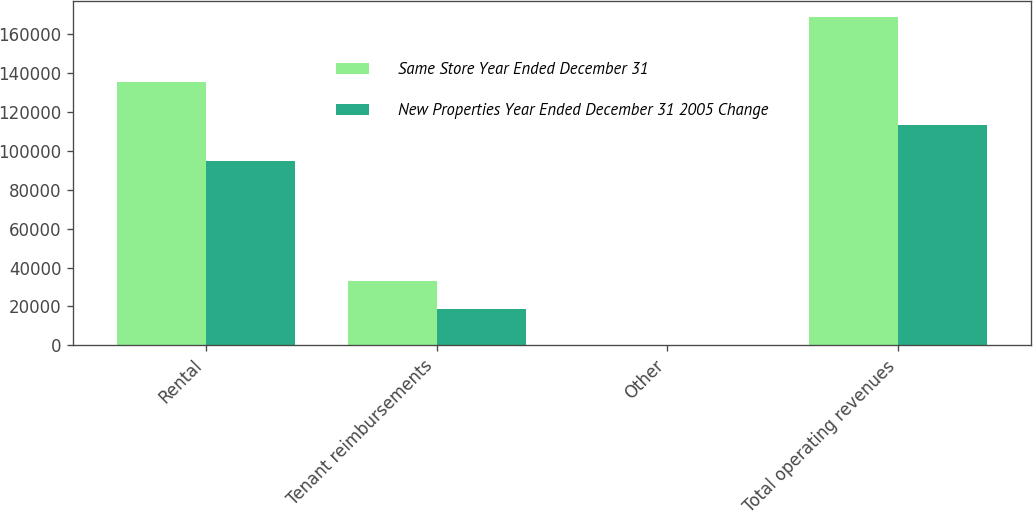Convert chart. <chart><loc_0><loc_0><loc_500><loc_500><stacked_bar_chart><ecel><fcel>Rental<fcel>Tenant reimbursements<fcel>Other<fcel>Total operating revenues<nl><fcel>Same Store Year Ended December 31<fcel>135031<fcel>33317<fcel>197<fcel>168545<nl><fcel>New Properties Year Ended December 31 2005 Change<fcel>94711<fcel>18479<fcel>168<fcel>113358<nl></chart> 